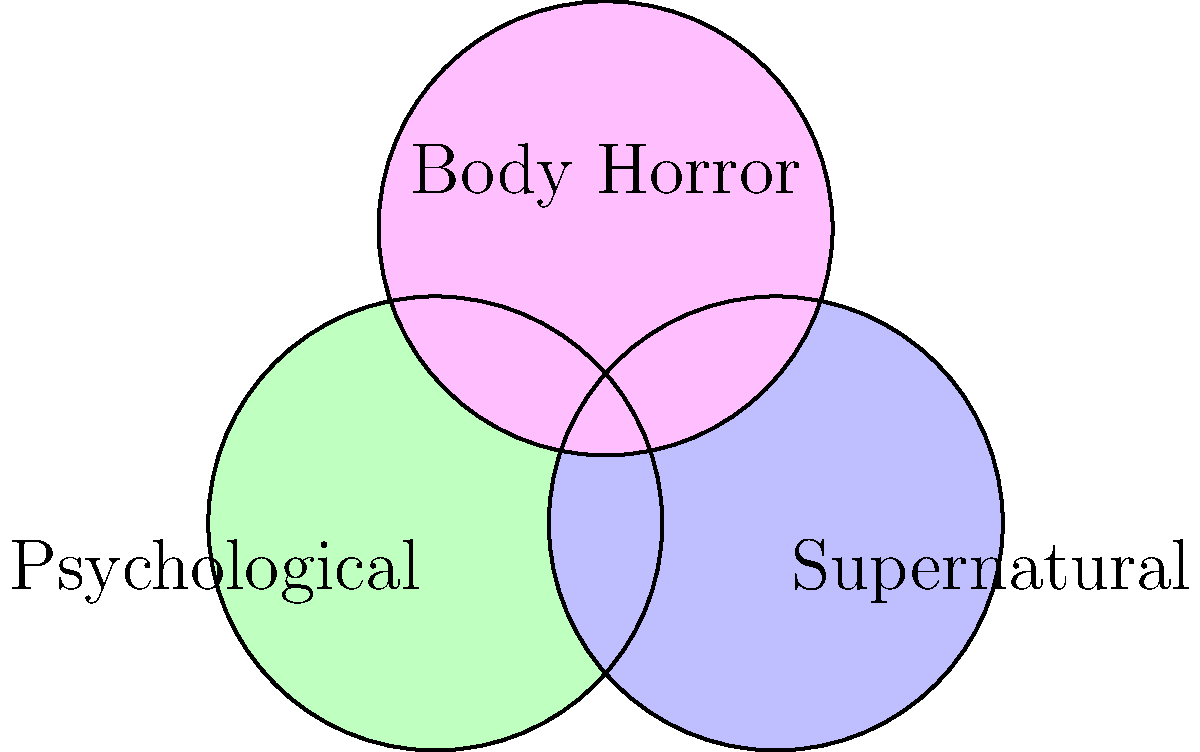In a Venn diagram representing horror subgenres, three circles with radius 1 unit are arranged as shown. The centers of the circles form an isosceles triangle with base 1.5 units and height 1.3 units. Calculate the total area covered by at least one horror subgenre (i.e., the area within at least one circle). To solve this problem, we'll follow these steps:

1) First, calculate the area of a single circle:
   $A_{circle} = \pi r^2 = \pi (1)^2 = \pi$

2) Calculate the total area of all three circles:
   $A_{total} = 3\pi$

3) Now, we need to subtract the areas of overlap. Let's start with the overlap between two circles:
   
   The distance between centers (d) can be calculated using the Pythagorean theorem:
   $d = \sqrt{1.5^2 + 1.3^2} \approx 1.98$

   The area of overlap for two circles is given by:
   $A_{overlap} = 2r^2 \arccos(\frac{d}{2r}) - d\sqrt{r^2 - (\frac{d}{2})^2}$

   Substituting our values:
   $A_{overlap} = 2(1)^2 \arccos(\frac{1.98}{2(1)}) - 1.98\sqrt{1^2 - (\frac{1.98}{2})^2} \approx 0.27$

4) There are three such overlaps (one for each pair of circles).

5) Finally, we need to add back the area where all three circles overlap. This is approximately the area of a small equilateral triangle at the center, which is negligible compared to the other areas.

6) Therefore, the total area covered is:
   $A_{covered} \approx 3\pi - 3(0.27) = 3\pi - 0.81 \approx 8.60$
Answer: $8.60$ square units 